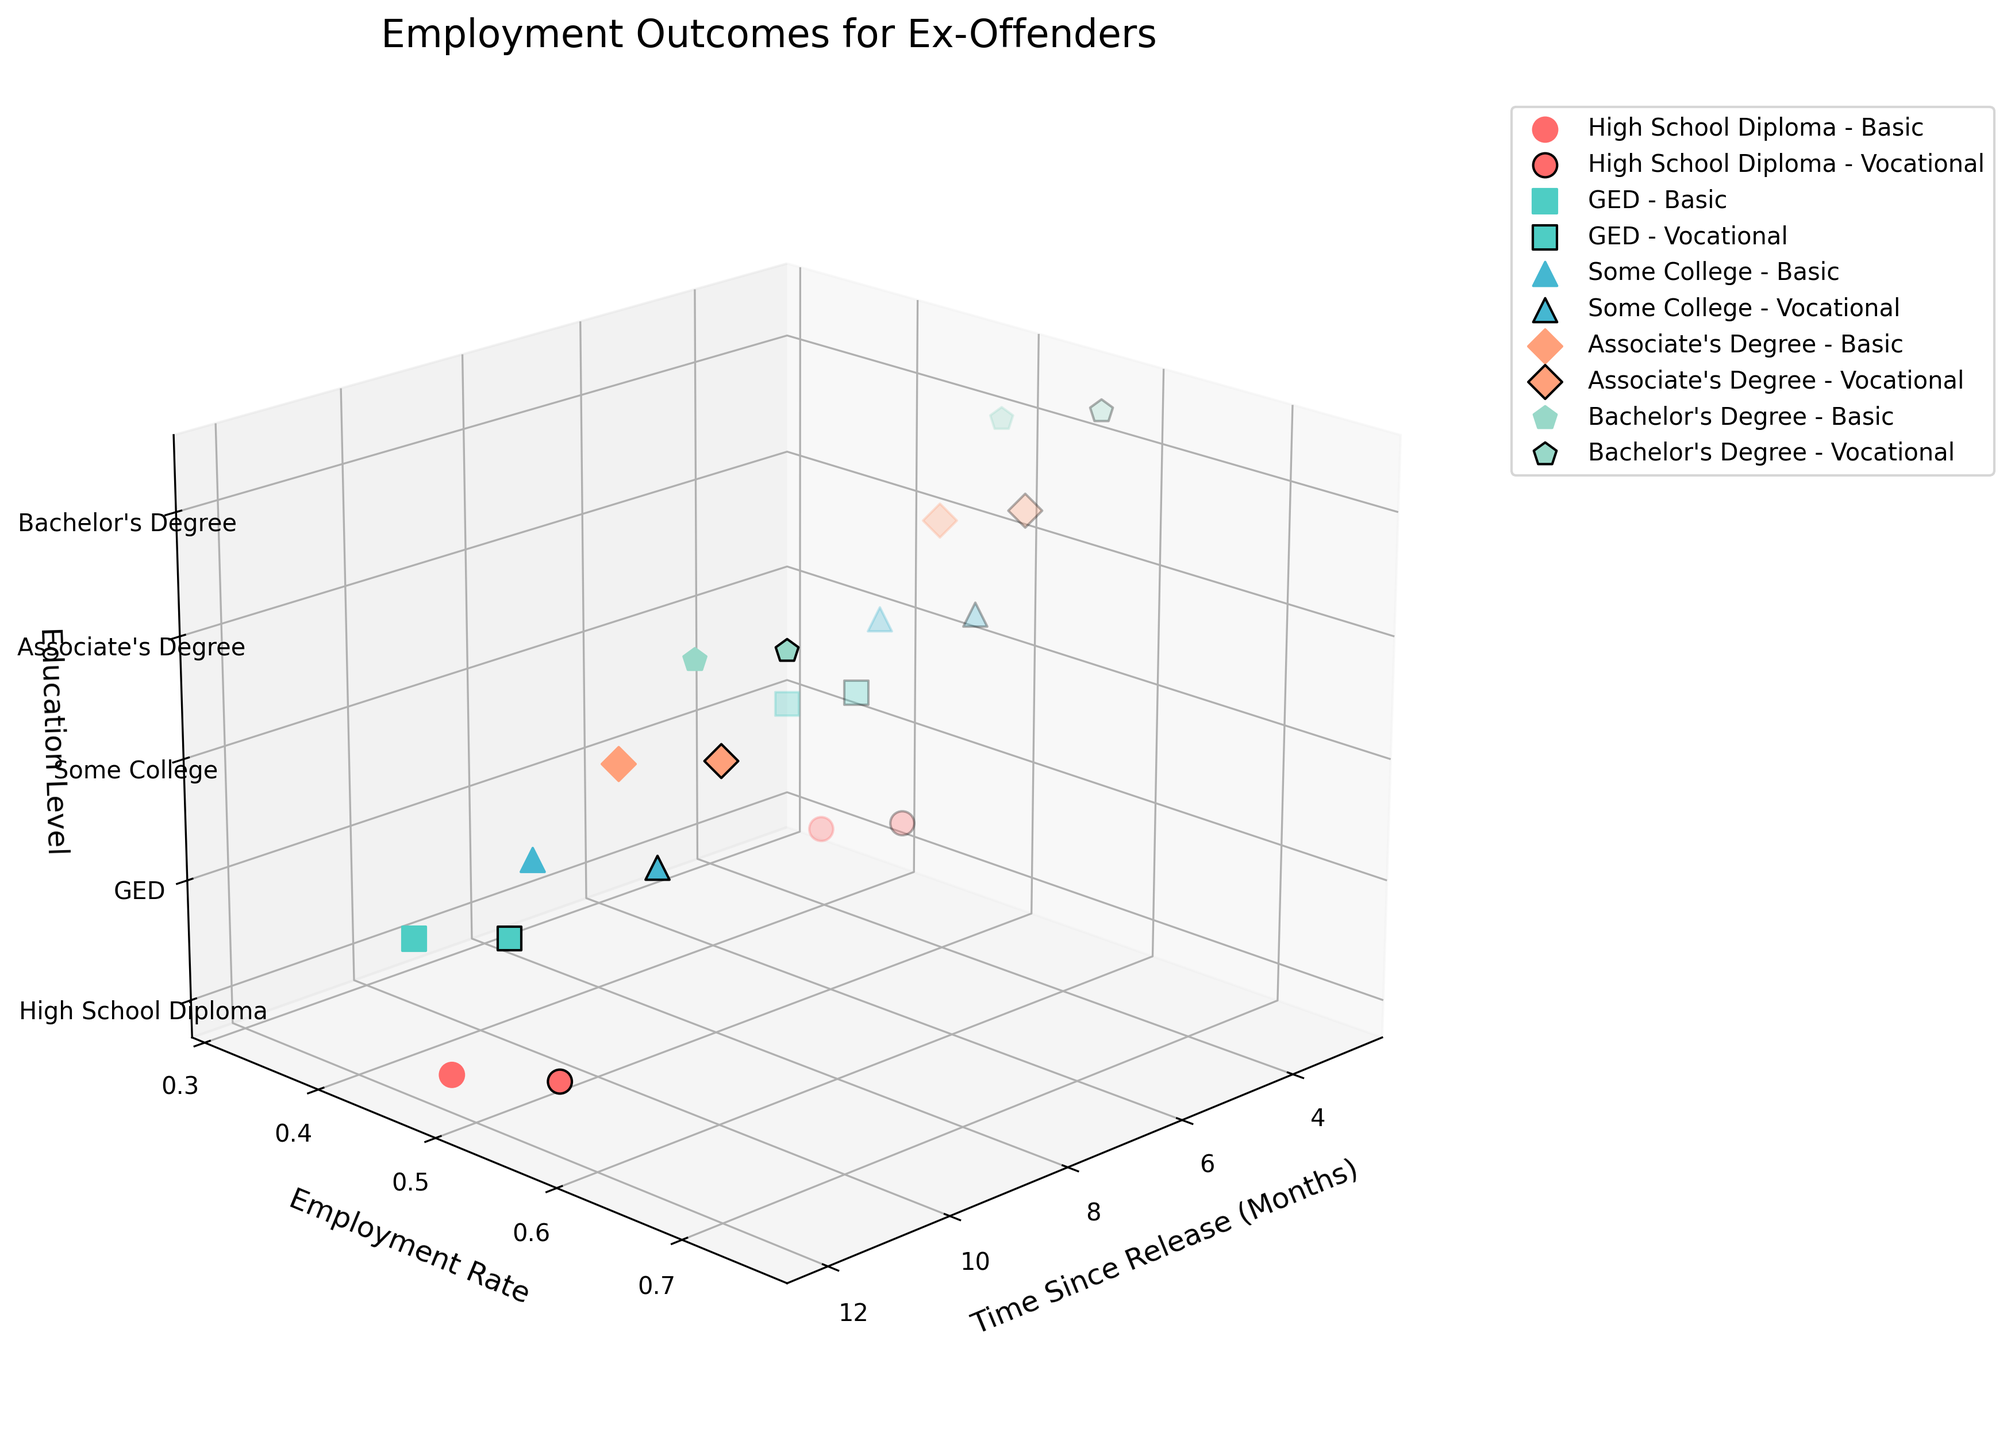What is the title of the figure? The title of the figure is located at the top of the plot, which typically labels the content and purpose of the visualization.
Answer: Employment Outcomes for Ex-Offenders Which education level has the highest employment rate 12 months after release? The highest employment rate markers for each education level at 12 months are shown on the y-axis and z-axis. The level with the highest y-axis value at 12 months (x-axis) should be selected.
Answer: Bachelor's Degree How does employment rate change for those with a GED after receiving vocational training from 3 months to 12 months? To determine the change, look for the GED education level markers with vocational training at 3 and 12 months, and then compare their employment rate values.
Answer: Increases from 0.38 to 0.53 Is there a difference in the employment rate at 3 months between basic and vocational training for individuals with Some College education? To compare, locate the employment rate values at 3 months for Some College with both basic and vocational training, then check for a difference.
Answer: Yes, vocational training (0.48) is higher than basic skills (0.40) What is the overall trend in employment rates based on education levels? By observing the z-axis and the corresponding employment rates on the y-axis, identify if higher education levels generally lead to higher employment rates.
Answer: Higher education levels correlate with higher employment rates Which education level has the steepest increase in employment rate from 3 to 12 months for those who received basic skills training? Determine the increase by finding the education level with the largest difference in employment rates (y-axis) from 3 to 12 months (x-axis) for basic skills training.
Answer: Associate's Degree (0.45 to 0.62) with an increase of 0.17 How does the employment rate for those with a High School Diploma and vocational training at 12 months compare to those with an Associate's Degree and basic skills training at 12 months? Compare the employment rate values for both categories at 12 months by cross-referencing the markers on the z and y axes.
Answer: 0.57 vs. 0.62 What can be inferred about the impact of vocational training versus basic skills training on employment rates? By comparing the employment rate markers across different education levels and training types, observe if vocational training generally leads to higher rates than basic skills.
Answer: Vocational training tends to have a higher impact Are there any education levels where the employment rate decreases from 3 to 12 months for a particular training type? Check all markers for different education levels and training types to see if any employment rates on the y-axis are lower at 12 months compared to 3 months.
Answer: No, all education levels show an increase 